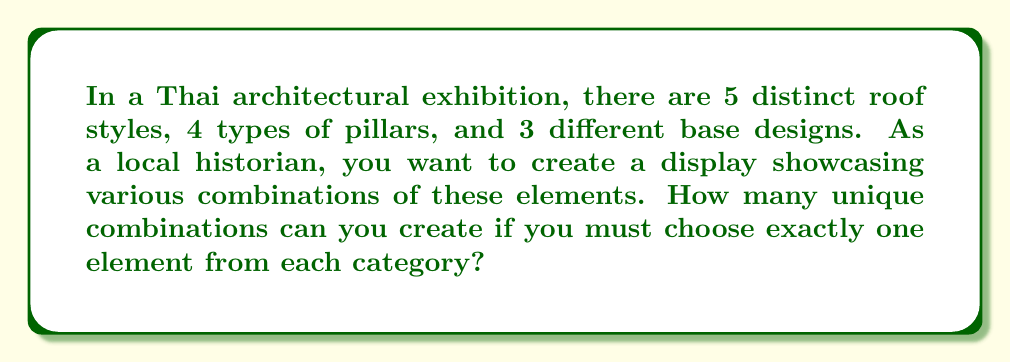Help me with this question. Let's approach this step-by-step using the multiplication principle of counting:

1) We have three independent choices to make:
   - One choice from 5 roof styles
   - One choice from 4 pillar types
   - One choice from 3 base designs

2) For each choice, we can use any of the available options, regardless of our other choices.

3) According to the multiplication principle, when we have a series of independent choices, we multiply the number of options for each choice to get the total number of possible combinations.

4) Therefore, the total number of unique combinations is:

   $$ 5 \times 4 \times 3 = 60 $$

5) This can be interpreted as:
   - For each of the 5 roof styles, we have 4 choices of pillars
   - For each of these 20 roof-pillar combinations, we have 3 choices of base designs

Thus, we end up with 60 unique combinations of Thai architectural elements.
Answer: 60 combinations 